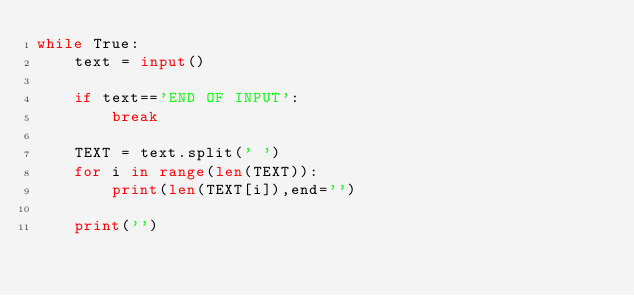Convert code to text. <code><loc_0><loc_0><loc_500><loc_500><_Python_>while True:
    text = input()
    
    if text=='END OF INPUT':
        break
    
    TEXT = text.split(' ')
    for i in range(len(TEXT)):
        print(len(TEXT[i]),end='')
    
    print('')
</code> 